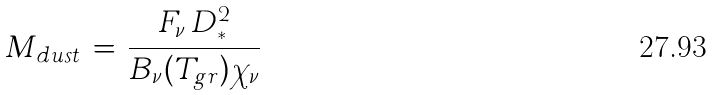<formula> <loc_0><loc_0><loc_500><loc_500>M _ { d u s t } \, = \, \frac { F _ { \nu } \, D _ { * } ^ { 2 } } { B _ { \nu } ( T _ { g r } ) { \chi } _ { \nu } }</formula> 